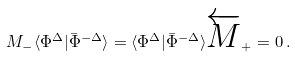Convert formula to latex. <formula><loc_0><loc_0><loc_500><loc_500>M _ { - } \langle \Phi ^ { \Delta } | \bar { \Phi } ^ { - \Delta } \rangle = \langle \Phi ^ { \Delta } | \bar { \Phi } ^ { - \Delta } \rangle \overleftarrow { M } _ { + } = 0 \, .</formula> 